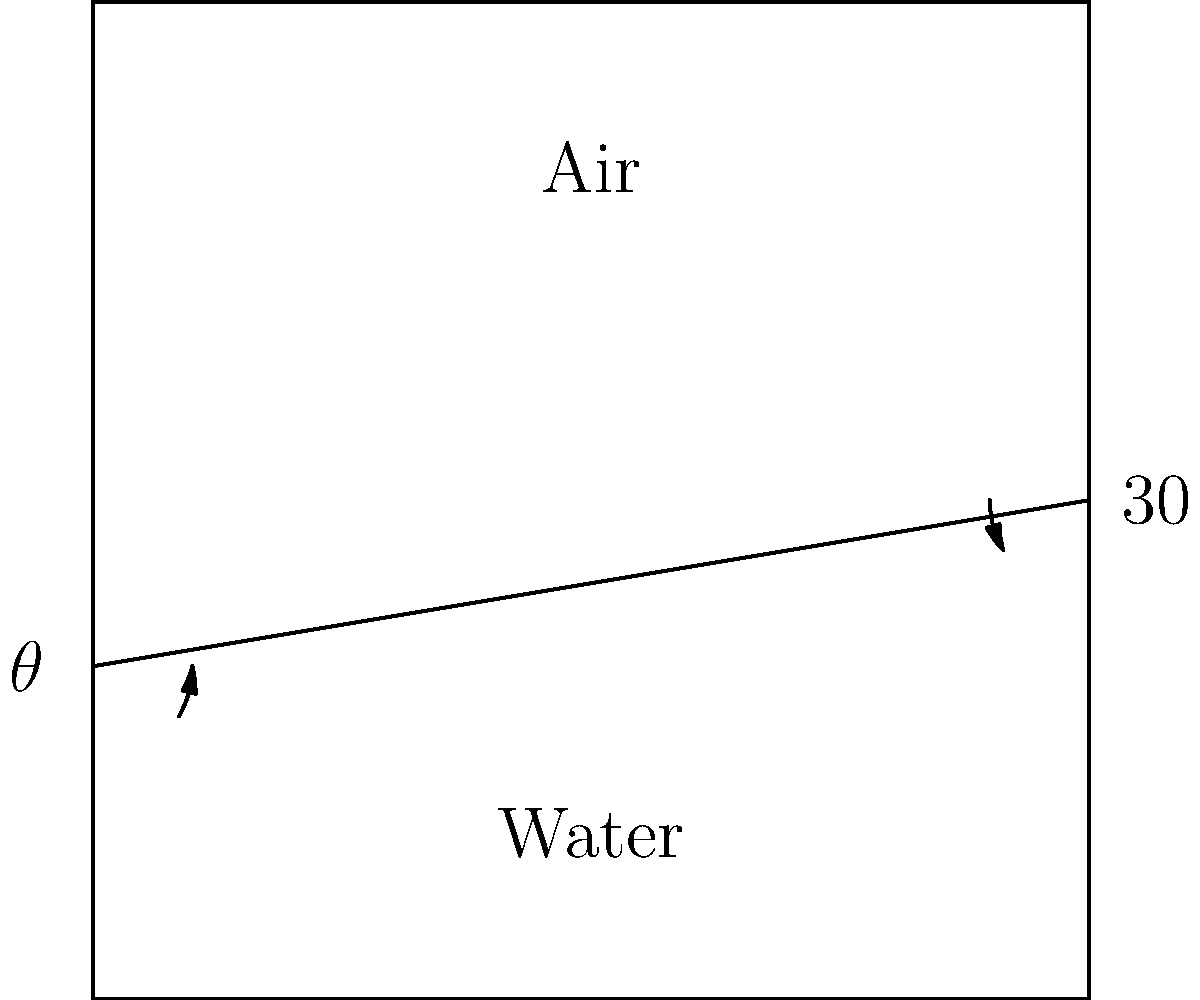As an operations research analyst optimizing game strategies, you're developing a model for a submarine-based game. A critical component involves understanding light refraction for periscope functionality. Given that light travels from air to water at a $30°$ angle to the normal, and the refractive index of water is 1.33, what is the angle of refraction $\theta$ in the water? Let's approach this step-by-step using Snell's Law:

1) Snell's Law states: $n_1 \sin(\theta_1) = n_2 \sin(\theta_2)$

   Where:
   - $n_1$ is the refractive index of the first medium (air)
   - $n_2$ is the refractive index of the second medium (water)
   - $\theta_1$ is the angle of incidence
   - $\theta_2$ is the angle of refraction

2) We know:
   - $n_1 = 1$ (refractive index of air)
   - $n_2 = 1.33$ (refractive index of water)
   - $\theta_1 = 30°$
   - $\theta_2 = \theta$ (what we're solving for)

3) Plugging these into Snell's Law:

   $1 \sin(30°) = 1.33 \sin(\theta)$

4) Simplify the left side:

   $0.5 = 1.33 \sin(\theta)$

5) Solve for $\sin(\theta)$:

   $\sin(\theta) = \frac{0.5}{1.33} \approx 0.3759$

6) Take the inverse sine (arcsin) of both sides:

   $\theta = \arcsin(0.3759) \approx 22.08°$

7) Round to two decimal places:

   $\theta \approx 22.08°$
Answer: $22.08°$ 